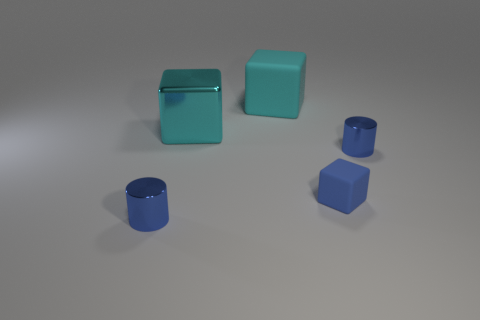There is a cube that is the same color as the big matte object; what is it made of?
Give a very brief answer. Metal. Do the cylinder that is right of the tiny matte cube and the tiny blue block have the same material?
Make the answer very short. No. There is a shiny cylinder that is right of the blue cylinder in front of the small rubber object; are there any cyan objects left of it?
Your answer should be compact. Yes. How many cubes are either small blue matte objects or small blue metal objects?
Ensure brevity in your answer.  1. What material is the cylinder that is right of the large cyan matte block?
Give a very brief answer. Metal. What size is the metallic block that is the same color as the large matte block?
Your answer should be very brief. Large. Does the tiny shiny thing to the left of the tiny blue cube have the same color as the metallic cylinder that is on the right side of the big metallic thing?
Ensure brevity in your answer.  Yes. How many things are big blue cylinders or cyan metallic blocks?
Make the answer very short. 1. Do the tiny cylinder that is on the left side of the tiny blue matte cube and the cyan cube behind the big cyan shiny thing have the same material?
Your answer should be very brief. No. There is a metal object that is both left of the small blue cube and in front of the cyan metal object; what is its shape?
Give a very brief answer. Cylinder. 